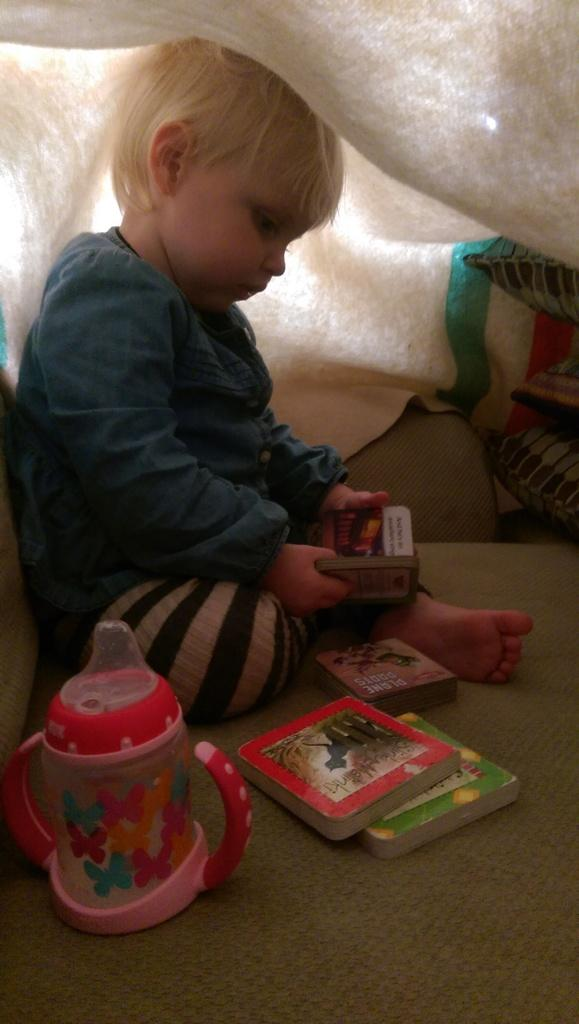What is the main subject of the picture? The main subject of the picture is a baby. What is the baby doing in the picture? The baby is sitting and reading a book. What is covering the baby in the picture? The baby is under a blanket. What type of lead is the baby holding in the picture? There is no lead present in the image; the baby is reading a book. Can you see any jellyfish in the picture? There are no jellyfish present in the image. 